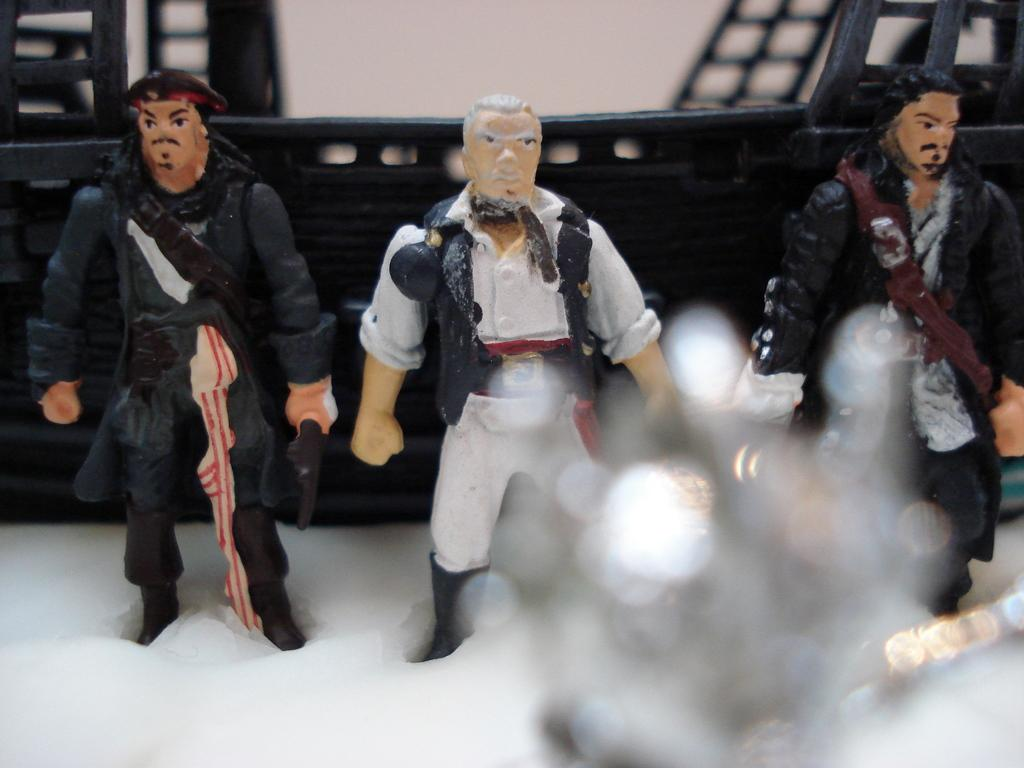What type of objects are present in the image? There are toys in the image. Can you describe the toys in more detail? The toys are of 3 pirates. What position are the pirate toys in? The pirate toys are standing. How many cherries are on top of the pirate toys in the image? There are no cherries present in the image; it features pirate toys. 